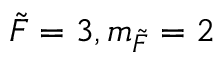<formula> <loc_0><loc_0><loc_500><loc_500>\tilde { F } = 3 , m _ { \tilde { F } } = 2</formula> 